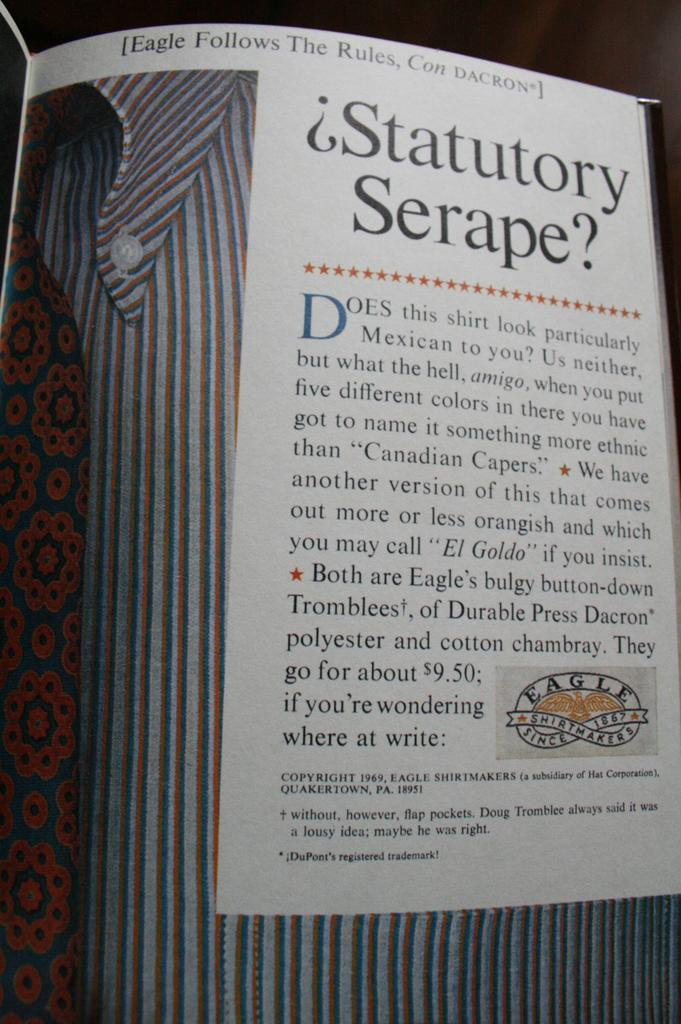<image>
Share a concise interpretation of the image provided. the word statutory is inside of a magazine 